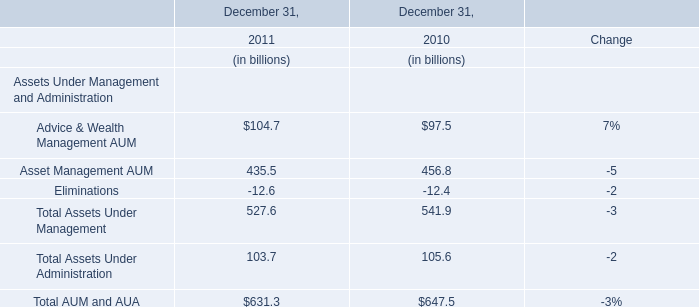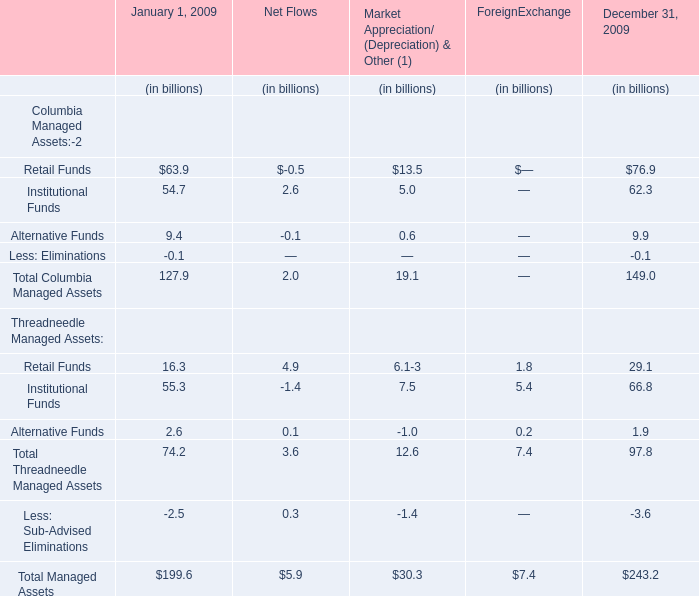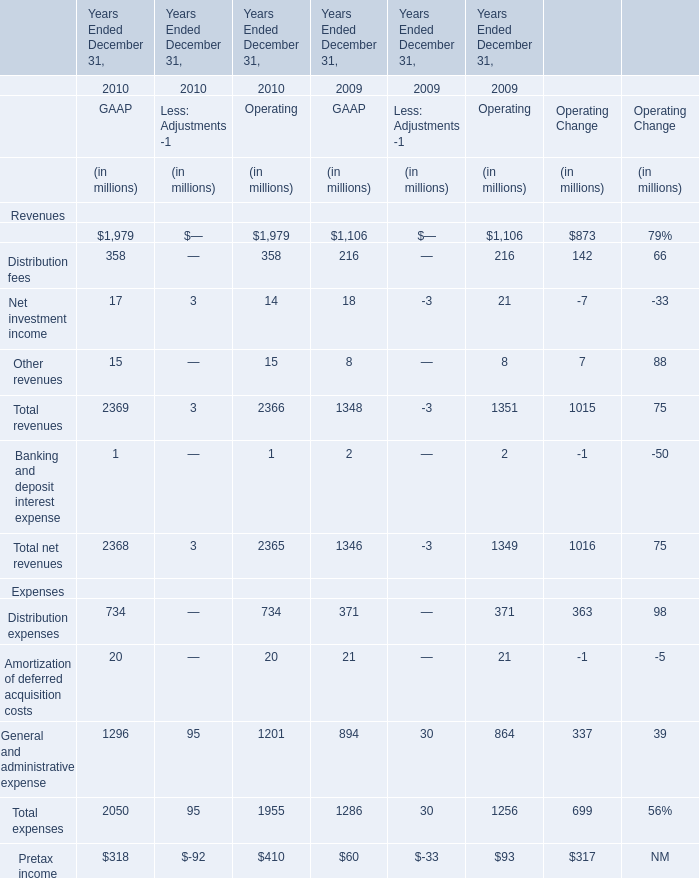What's the sum of Revenues without those Other revenues smaller than 1000 in 2010? (in million) 
Computations: (358 + 17)
Answer: 375.0. 